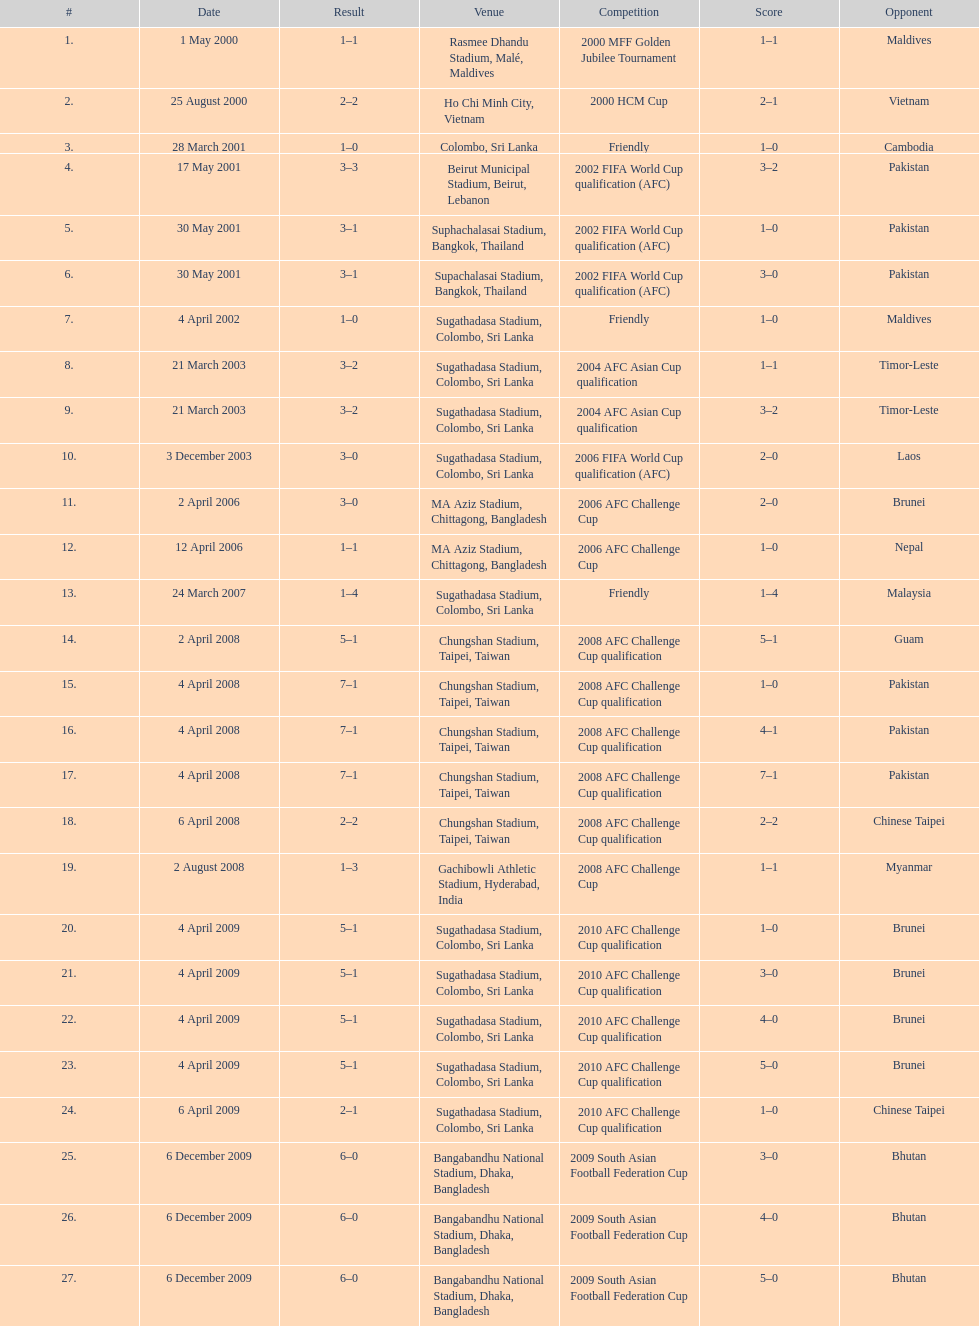What was the subsequent location after colombo, sri lanka on march 28? Beirut Municipal Stadium, Beirut, Lebanon. 